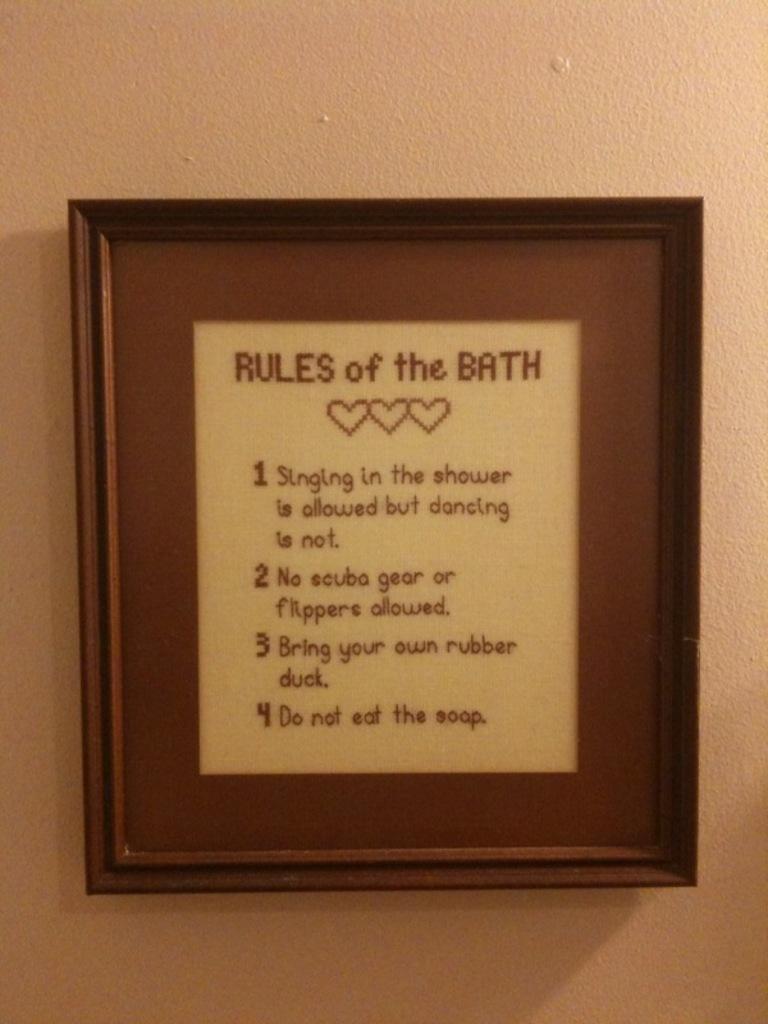How many rules of the bath are there?
Your answer should be very brief. 4. What are the rules for?
Keep it short and to the point. The bath. 